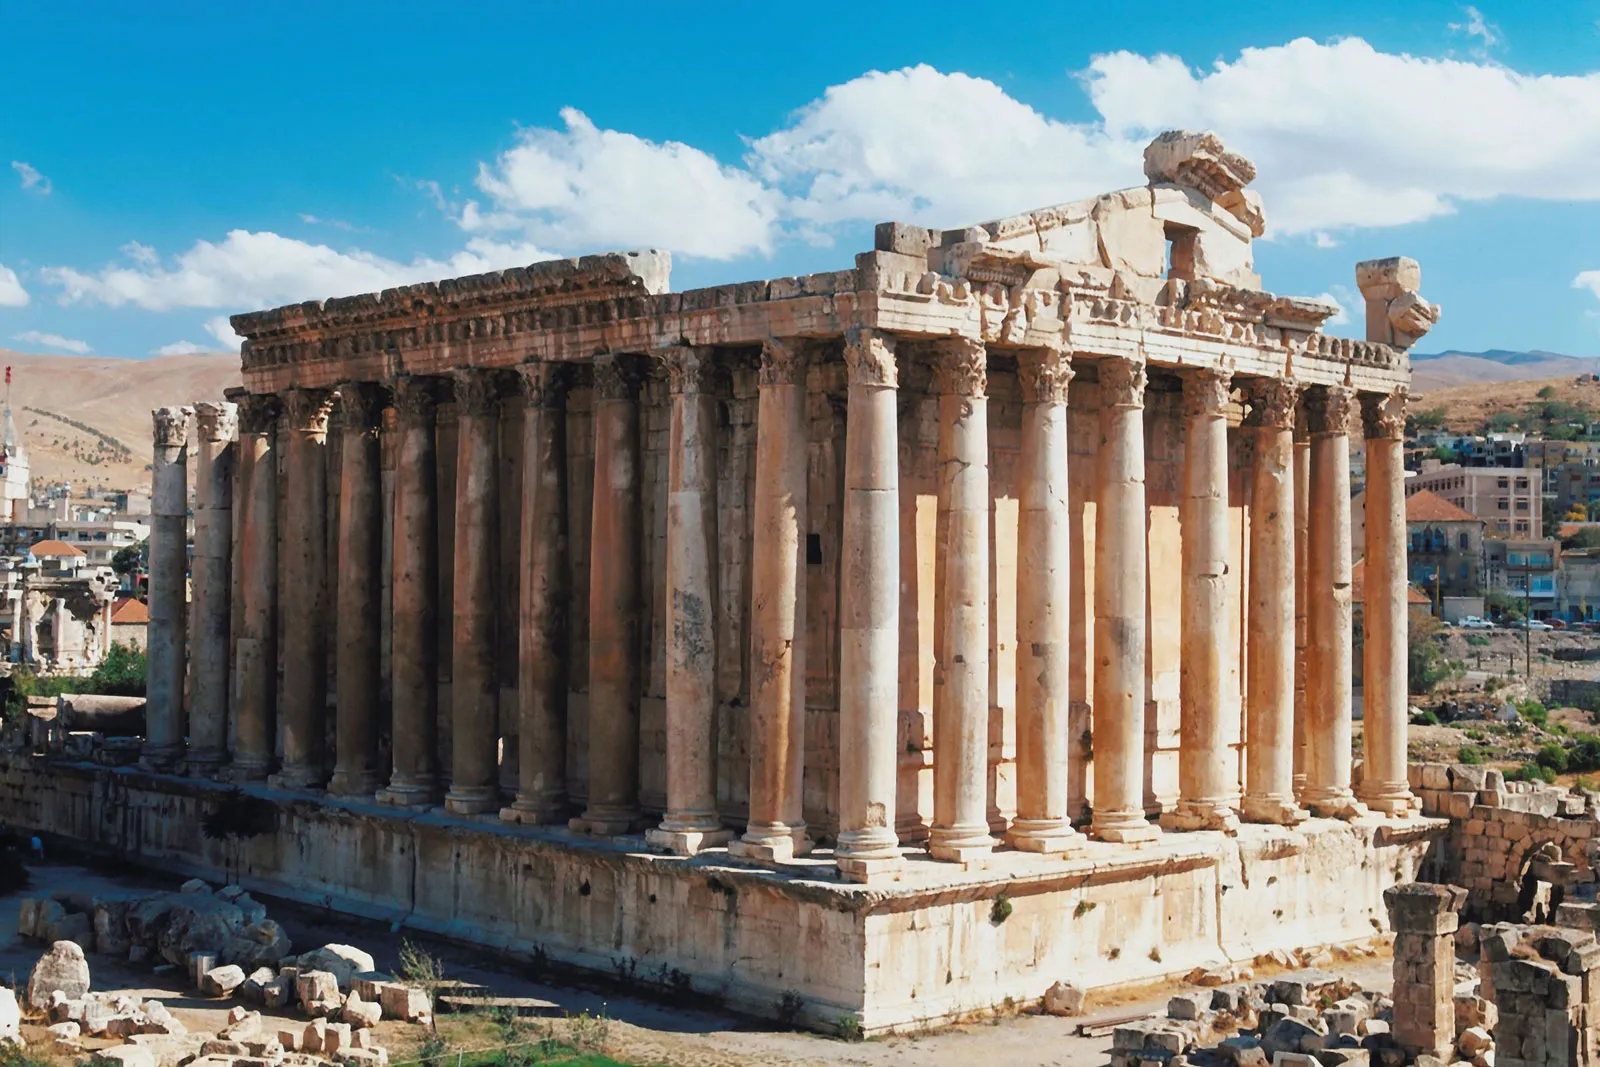What do you see happening in this image? The image captures the grandeur of the ancient Temple of Jupiter, located in Baalbek, Lebanon. The temple, a testament to the architectural prowess of the past, stands majestically on a hill, overlooking the city and the mountains in the distance. The structure is rectangular, surrounded by a series of tall columns made of light-colored stone, each adorned with ornate capitals that add to the overall elegance of the temple. The perspective of the image is slightly elevated, offering a panoramic view of the surrounding landscape under the clear blue sky. The image is a beautiful blend of history, architecture, and nature, encapsulating the essence of this worldwide landmark. 